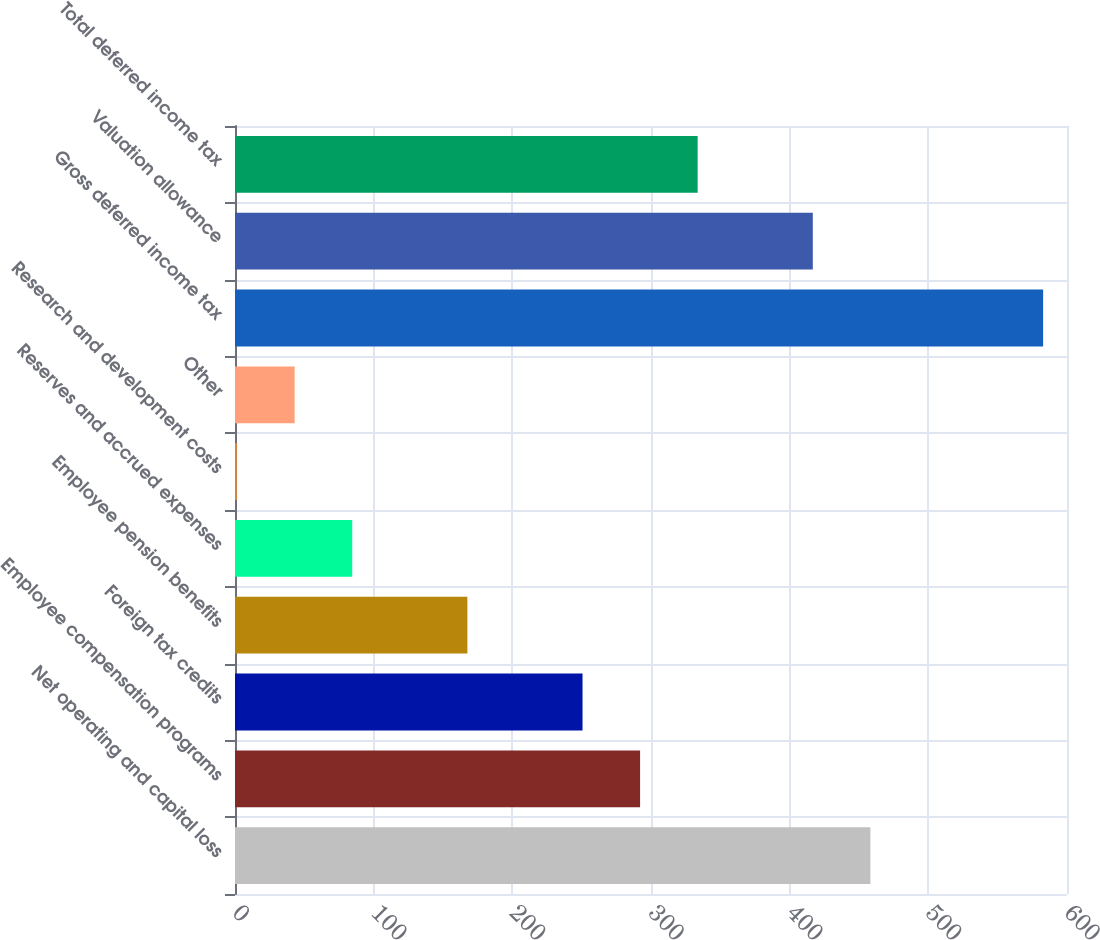<chart> <loc_0><loc_0><loc_500><loc_500><bar_chart><fcel>Net operating and capital loss<fcel>Employee compensation programs<fcel>Foreign tax credits<fcel>Employee pension benefits<fcel>Reserves and accrued expenses<fcel>Research and development costs<fcel>Other<fcel>Gross deferred income tax<fcel>Valuation allowance<fcel>Total deferred income tax<nl><fcel>458.22<fcel>292.14<fcel>250.62<fcel>167.58<fcel>84.54<fcel>1.5<fcel>43.02<fcel>582.78<fcel>416.7<fcel>333.66<nl></chart> 